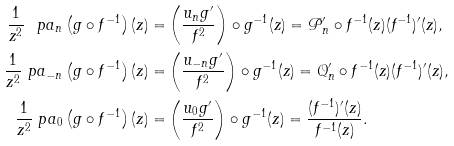Convert formula to latex. <formula><loc_0><loc_0><loc_500><loc_500>\frac { 1 } { z ^ { 2 } } \ p a _ { n } \left ( g \circ f ^ { - 1 } \right ) ( z ) = & \left ( \frac { u _ { n } g ^ { \prime } } { f ^ { 2 } } \right ) \circ g ^ { - 1 } ( z ) = \mathcal { P } _ { n } ^ { \prime } \circ f ^ { - 1 } ( z ) ( f ^ { - 1 } ) ^ { \prime } ( z ) , \\ \frac { 1 } { z ^ { 2 } } \ p a _ { - n } \left ( g \circ f ^ { - 1 } \right ) ( z ) = & \left ( \frac { u _ { - n } g ^ { \prime } } { f ^ { 2 } } \right ) \circ g ^ { - 1 } ( z ) = \mathcal { Q } _ { n } ^ { \prime } \circ f ^ { - 1 } ( z ) ( f ^ { - 1 } ) ^ { \prime } ( z ) , \\ \frac { 1 } { z ^ { 2 } } \ p a _ { 0 } \left ( g \circ f ^ { - 1 } \right ) ( z ) = & \left ( \frac { u _ { 0 } g ^ { \prime } } { f ^ { 2 } } \right ) \circ g ^ { - 1 } ( z ) = \frac { ( f ^ { - 1 } ) ^ { \prime } ( z ) } { f ^ { - 1 } ( z ) } .</formula> 